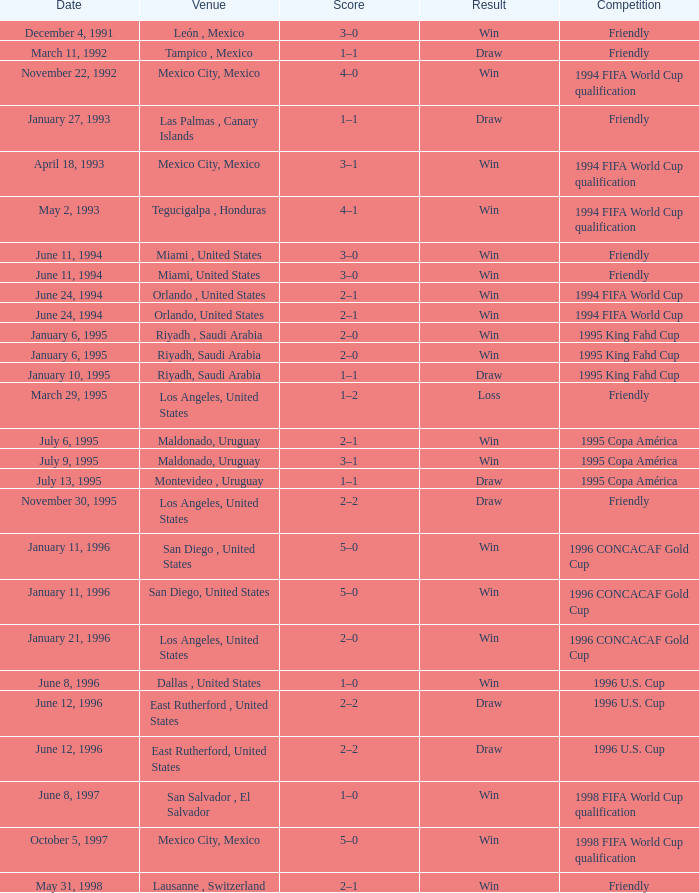What is the score, when the place is riyadh, saudi arabia, and the result is "victory"? 2–0, 2–0. 